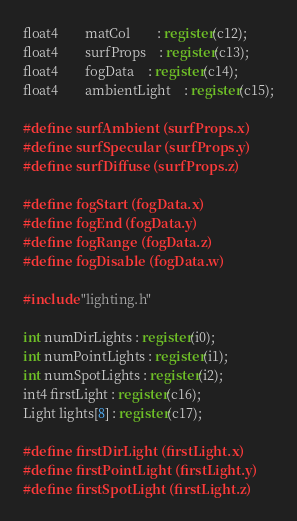<code> <loc_0><loc_0><loc_500><loc_500><_C_>float4		matCol		: register(c12);
float4		surfProps	: register(c13);
float4		fogData	: register(c14);
float4		ambientLight	: register(c15);

#define surfAmbient (surfProps.x)
#define surfSpecular (surfProps.y)
#define surfDiffuse (surfProps.z)

#define fogStart (fogData.x)
#define fogEnd (fogData.y)
#define fogRange (fogData.z)
#define fogDisable (fogData.w)

#include "lighting.h"

int numDirLights : register(i0);
int numPointLights : register(i1);
int numSpotLights : register(i2);
int4 firstLight : register(c16);
Light lights[8] : register(c17);

#define firstDirLight (firstLight.x)
#define firstPointLight (firstLight.y)
#define firstSpotLight (firstLight.z)
</code> 